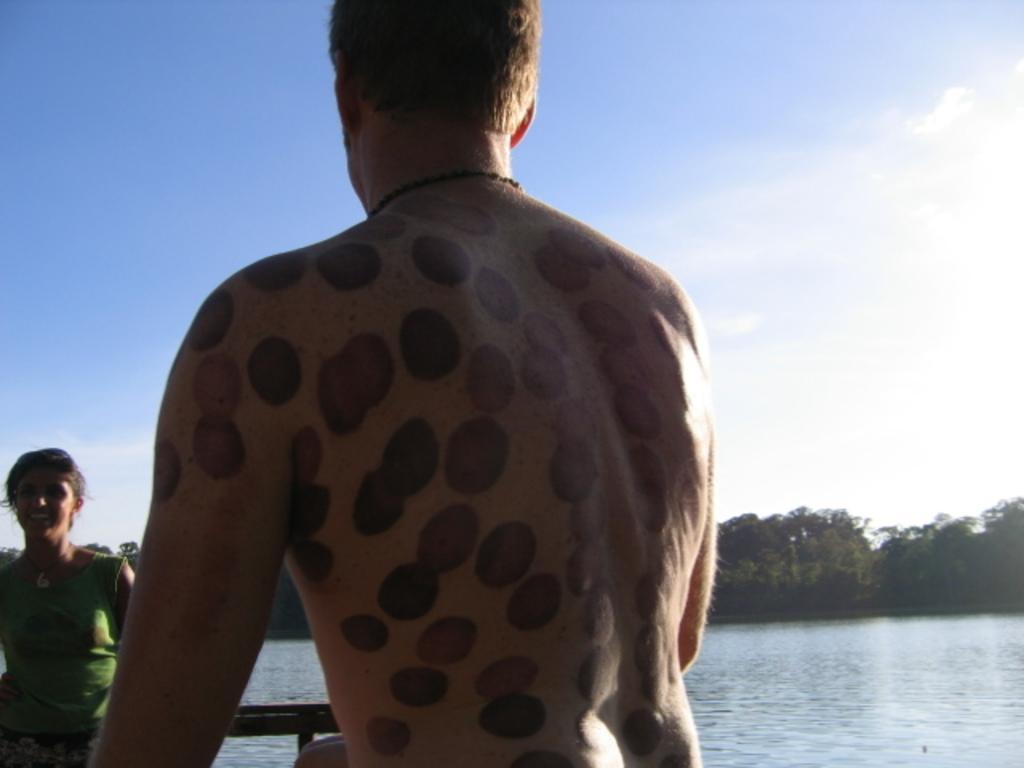Describe this image in one or two sentences. In this image there is a man standing on the bridge. There are round tattoos all over his body. On the left side there is a girl who is smiling. She is also standing on the bridge. At the bottom there is water. In the background there are trees. At the top there is the sky. 